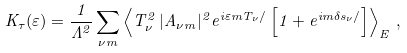<formula> <loc_0><loc_0><loc_500><loc_500>K _ { \tau } ( \varepsilon ) = \frac { 1 } { \Lambda ^ { 2 } } \sum _ { \nu m } \left \langle T ^ { 2 } _ { \nu } \, | A _ { \nu m } | ^ { 2 } e ^ { i \varepsilon m T _ { \nu } / } \left [ 1 + e ^ { i m \delta { s } _ { \nu } / } \right ] \right \rangle _ { E } \, ,</formula> 